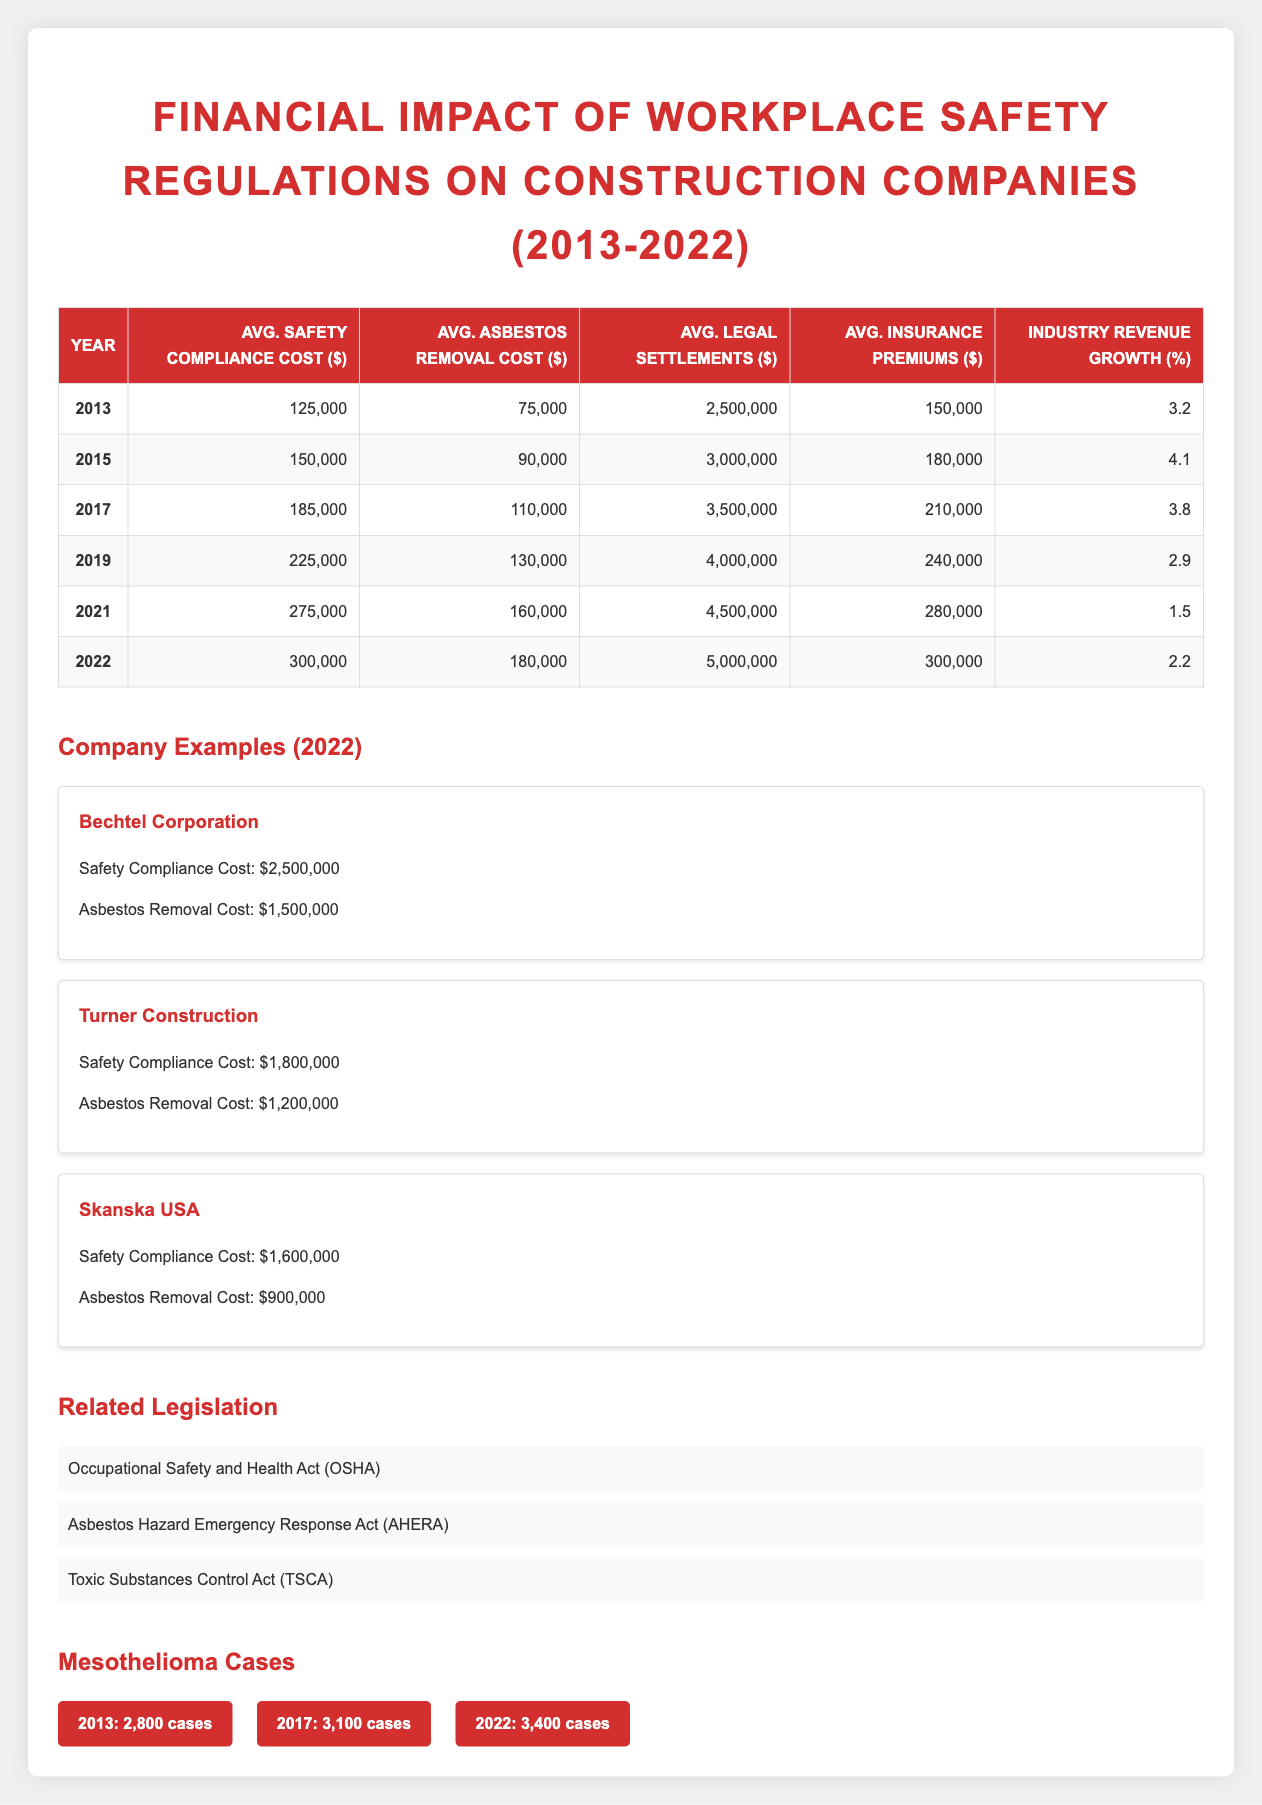What was the average safety compliance cost in 2019? Looking at the table for the year 2019, the average safety compliance cost is 225,000 dollars.
Answer: 225,000 What was the total average asbestos removal cost from 2013 to 2022? To find the total, add the average asbestos removal costs for each year: 75,000 + 90,000 + 110,000 + 130,000 + 160,000 + 180,000 = 845,000 dollars.
Answer: 845,000 Was the average legal settlement higher in 2022 than in 2021? In 2022, the average legal settlement is 5,000,000 dollars, and in 2021, it is 4,500,000 dollars. Since 5,000,000 is greater than 4,500,000, the statement is true.
Answer: Yes What is the average increase in safety compliance costs from 2013 to 2022? Calculate the increase from 2013 to 2022: 300,000 - 125,000 = 175,000 dollars. To find the average increase over the 9 years, divide by the number of intervals (9): 175,000 / 9 = approximately 19,444.44 dollars per year.
Answer: 19,444.44 Did the construction industry experience a consistent revenue growth over the years from 2013 to 2022? Looking at the revenue growth percentages: 3.2, 4.1, 3.8, 2.9, 1.5, and 2.2, it's clear that the values fluctuate rather than consistently increasing or decreasing. Therefore, the statement is false.
Answer: No What was the highest average insurance premium and in which year was it recorded? The highest average insurance premium is 300,000 dollars, which was recorded in 2022, as shown in the relevant row of the table.
Answer: 300,000 in 2022 By how much did the average legal settlements increase from 2015 to 2022? The average legal settlements in 2015 were 3,000,000 dollars, and in 2022, they were 5,000,000 dollars. The increase is calculated as 5,000,000 - 3,000,000 = 2,000,000 dollars.
Answer: 2,000,000 What percentage of revenue growth was recorded in 2019? The table shows that the industry revenue growth percentage for 2019 is 2.9. Therefore, that is the answer.
Answer: 2.9 How many mesothelioma cases were reported in 2017? According to the mesothelioma cases section, there were 3,100 cases reported in 2017.
Answer: 3,100 